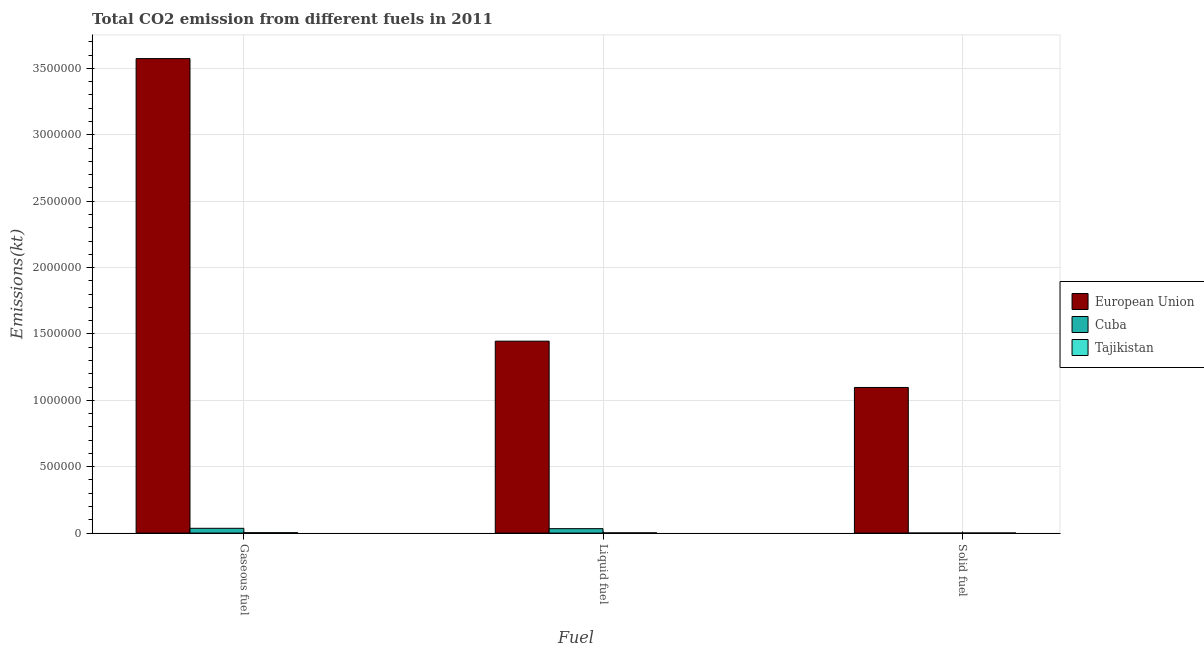How many groups of bars are there?
Your response must be concise. 3. Are the number of bars per tick equal to the number of legend labels?
Offer a terse response. Yes. Are the number of bars on each tick of the X-axis equal?
Give a very brief answer. Yes. How many bars are there on the 1st tick from the right?
Make the answer very short. 3. What is the label of the 2nd group of bars from the left?
Ensure brevity in your answer.  Liquid fuel. What is the amount of co2 emissions from solid fuel in Tajikistan?
Your response must be concise. 348.37. Across all countries, what is the maximum amount of co2 emissions from liquid fuel?
Your answer should be very brief. 1.45e+06. Across all countries, what is the minimum amount of co2 emissions from solid fuel?
Offer a terse response. 11. In which country was the amount of co2 emissions from gaseous fuel maximum?
Your answer should be very brief. European Union. In which country was the amount of co2 emissions from liquid fuel minimum?
Offer a terse response. Tajikistan. What is the total amount of co2 emissions from gaseous fuel in the graph?
Your answer should be very brief. 3.61e+06. What is the difference between the amount of co2 emissions from liquid fuel in European Union and that in Tajikistan?
Your response must be concise. 1.44e+06. What is the difference between the amount of co2 emissions from solid fuel in Tajikistan and the amount of co2 emissions from gaseous fuel in Cuba?
Provide a succinct answer. -3.56e+04. What is the average amount of co2 emissions from gaseous fuel per country?
Your answer should be compact. 1.20e+06. What is the difference between the amount of co2 emissions from liquid fuel and amount of co2 emissions from gaseous fuel in European Union?
Provide a succinct answer. -2.13e+06. In how many countries, is the amount of co2 emissions from solid fuel greater than 1000000 kt?
Your answer should be very brief. 1. What is the ratio of the amount of co2 emissions from liquid fuel in Cuba to that in European Union?
Give a very brief answer. 0.02. Is the amount of co2 emissions from gaseous fuel in Cuba less than that in Tajikistan?
Your response must be concise. No. What is the difference between the highest and the second highest amount of co2 emissions from solid fuel?
Your response must be concise. 1.10e+06. What is the difference between the highest and the lowest amount of co2 emissions from gaseous fuel?
Ensure brevity in your answer.  3.57e+06. In how many countries, is the amount of co2 emissions from solid fuel greater than the average amount of co2 emissions from solid fuel taken over all countries?
Provide a succinct answer. 1. What does the 2nd bar from the left in Gaseous fuel represents?
Keep it short and to the point. Cuba. What does the 2nd bar from the right in Solid fuel represents?
Make the answer very short. Cuba. Are all the bars in the graph horizontal?
Your answer should be very brief. No. Are the values on the major ticks of Y-axis written in scientific E-notation?
Keep it short and to the point. No. Does the graph contain any zero values?
Your response must be concise. No. Where does the legend appear in the graph?
Give a very brief answer. Center right. How many legend labels are there?
Provide a succinct answer. 3. What is the title of the graph?
Ensure brevity in your answer.  Total CO2 emission from different fuels in 2011. Does "Pacific island small states" appear as one of the legend labels in the graph?
Give a very brief answer. No. What is the label or title of the X-axis?
Ensure brevity in your answer.  Fuel. What is the label or title of the Y-axis?
Provide a short and direct response. Emissions(kt). What is the Emissions(kt) in European Union in Gaseous fuel?
Provide a short and direct response. 3.57e+06. What is the Emissions(kt) of Cuba in Gaseous fuel?
Provide a short and direct response. 3.59e+04. What is the Emissions(kt) of Tajikistan in Gaseous fuel?
Offer a terse response. 2783.25. What is the Emissions(kt) of European Union in Liquid fuel?
Ensure brevity in your answer.  1.45e+06. What is the Emissions(kt) of Cuba in Liquid fuel?
Give a very brief answer. 3.31e+04. What is the Emissions(kt) in Tajikistan in Liquid fuel?
Your answer should be very brief. 1481.47. What is the Emissions(kt) in European Union in Solid fuel?
Your answer should be compact. 1.10e+06. What is the Emissions(kt) of Cuba in Solid fuel?
Keep it short and to the point. 11. What is the Emissions(kt) in Tajikistan in Solid fuel?
Give a very brief answer. 348.37. Across all Fuel, what is the maximum Emissions(kt) of European Union?
Offer a very short reply. 3.57e+06. Across all Fuel, what is the maximum Emissions(kt) of Cuba?
Your answer should be compact. 3.59e+04. Across all Fuel, what is the maximum Emissions(kt) of Tajikistan?
Your answer should be very brief. 2783.25. Across all Fuel, what is the minimum Emissions(kt) in European Union?
Give a very brief answer. 1.10e+06. Across all Fuel, what is the minimum Emissions(kt) in Cuba?
Your response must be concise. 11. Across all Fuel, what is the minimum Emissions(kt) in Tajikistan?
Ensure brevity in your answer.  348.37. What is the total Emissions(kt) in European Union in the graph?
Make the answer very short. 6.12e+06. What is the total Emissions(kt) of Cuba in the graph?
Ensure brevity in your answer.  6.91e+04. What is the total Emissions(kt) in Tajikistan in the graph?
Make the answer very short. 4613.09. What is the difference between the Emissions(kt) in European Union in Gaseous fuel and that in Liquid fuel?
Keep it short and to the point. 2.13e+06. What is the difference between the Emissions(kt) in Cuba in Gaseous fuel and that in Liquid fuel?
Provide a succinct answer. 2772.25. What is the difference between the Emissions(kt) in Tajikistan in Gaseous fuel and that in Liquid fuel?
Your answer should be very brief. 1301.79. What is the difference between the Emissions(kt) in European Union in Gaseous fuel and that in Solid fuel?
Offer a terse response. 2.48e+06. What is the difference between the Emissions(kt) of Cuba in Gaseous fuel and that in Solid fuel?
Make the answer very short. 3.59e+04. What is the difference between the Emissions(kt) of Tajikistan in Gaseous fuel and that in Solid fuel?
Offer a terse response. 2434.89. What is the difference between the Emissions(kt) of European Union in Liquid fuel and that in Solid fuel?
Ensure brevity in your answer.  3.49e+05. What is the difference between the Emissions(kt) in Cuba in Liquid fuel and that in Solid fuel?
Offer a very short reply. 3.31e+04. What is the difference between the Emissions(kt) of Tajikistan in Liquid fuel and that in Solid fuel?
Provide a short and direct response. 1133.1. What is the difference between the Emissions(kt) of European Union in Gaseous fuel and the Emissions(kt) of Cuba in Liquid fuel?
Provide a succinct answer. 3.54e+06. What is the difference between the Emissions(kt) of European Union in Gaseous fuel and the Emissions(kt) of Tajikistan in Liquid fuel?
Offer a terse response. 3.57e+06. What is the difference between the Emissions(kt) in Cuba in Gaseous fuel and the Emissions(kt) in Tajikistan in Liquid fuel?
Keep it short and to the point. 3.44e+04. What is the difference between the Emissions(kt) in European Union in Gaseous fuel and the Emissions(kt) in Cuba in Solid fuel?
Your answer should be very brief. 3.57e+06. What is the difference between the Emissions(kt) in European Union in Gaseous fuel and the Emissions(kt) in Tajikistan in Solid fuel?
Give a very brief answer. 3.57e+06. What is the difference between the Emissions(kt) in Cuba in Gaseous fuel and the Emissions(kt) in Tajikistan in Solid fuel?
Your response must be concise. 3.56e+04. What is the difference between the Emissions(kt) in European Union in Liquid fuel and the Emissions(kt) in Cuba in Solid fuel?
Give a very brief answer. 1.45e+06. What is the difference between the Emissions(kt) in European Union in Liquid fuel and the Emissions(kt) in Tajikistan in Solid fuel?
Your response must be concise. 1.45e+06. What is the difference between the Emissions(kt) in Cuba in Liquid fuel and the Emissions(kt) in Tajikistan in Solid fuel?
Your answer should be very brief. 3.28e+04. What is the average Emissions(kt) of European Union per Fuel?
Your answer should be very brief. 2.04e+06. What is the average Emissions(kt) in Cuba per Fuel?
Provide a succinct answer. 2.30e+04. What is the average Emissions(kt) of Tajikistan per Fuel?
Make the answer very short. 1537.7. What is the difference between the Emissions(kt) of European Union and Emissions(kt) of Cuba in Gaseous fuel?
Offer a very short reply. 3.54e+06. What is the difference between the Emissions(kt) in European Union and Emissions(kt) in Tajikistan in Gaseous fuel?
Your response must be concise. 3.57e+06. What is the difference between the Emissions(kt) in Cuba and Emissions(kt) in Tajikistan in Gaseous fuel?
Give a very brief answer. 3.31e+04. What is the difference between the Emissions(kt) of European Union and Emissions(kt) of Cuba in Liquid fuel?
Your answer should be compact. 1.41e+06. What is the difference between the Emissions(kt) of European Union and Emissions(kt) of Tajikistan in Liquid fuel?
Your response must be concise. 1.44e+06. What is the difference between the Emissions(kt) in Cuba and Emissions(kt) in Tajikistan in Liquid fuel?
Make the answer very short. 3.17e+04. What is the difference between the Emissions(kt) in European Union and Emissions(kt) in Cuba in Solid fuel?
Your answer should be very brief. 1.10e+06. What is the difference between the Emissions(kt) in European Union and Emissions(kt) in Tajikistan in Solid fuel?
Make the answer very short. 1.10e+06. What is the difference between the Emissions(kt) of Cuba and Emissions(kt) of Tajikistan in Solid fuel?
Make the answer very short. -337.36. What is the ratio of the Emissions(kt) of European Union in Gaseous fuel to that in Liquid fuel?
Give a very brief answer. 2.47. What is the ratio of the Emissions(kt) of Cuba in Gaseous fuel to that in Liquid fuel?
Offer a terse response. 1.08. What is the ratio of the Emissions(kt) of Tajikistan in Gaseous fuel to that in Liquid fuel?
Give a very brief answer. 1.88. What is the ratio of the Emissions(kt) in European Union in Gaseous fuel to that in Solid fuel?
Make the answer very short. 3.26. What is the ratio of the Emissions(kt) in Cuba in Gaseous fuel to that in Solid fuel?
Your answer should be compact. 3265.33. What is the ratio of the Emissions(kt) of Tajikistan in Gaseous fuel to that in Solid fuel?
Provide a succinct answer. 7.99. What is the ratio of the Emissions(kt) in European Union in Liquid fuel to that in Solid fuel?
Offer a terse response. 1.32. What is the ratio of the Emissions(kt) in Cuba in Liquid fuel to that in Solid fuel?
Provide a short and direct response. 3013.33. What is the ratio of the Emissions(kt) of Tajikistan in Liquid fuel to that in Solid fuel?
Keep it short and to the point. 4.25. What is the difference between the highest and the second highest Emissions(kt) in European Union?
Your response must be concise. 2.13e+06. What is the difference between the highest and the second highest Emissions(kt) in Cuba?
Make the answer very short. 2772.25. What is the difference between the highest and the second highest Emissions(kt) of Tajikistan?
Your response must be concise. 1301.79. What is the difference between the highest and the lowest Emissions(kt) of European Union?
Keep it short and to the point. 2.48e+06. What is the difference between the highest and the lowest Emissions(kt) of Cuba?
Provide a succinct answer. 3.59e+04. What is the difference between the highest and the lowest Emissions(kt) of Tajikistan?
Offer a very short reply. 2434.89. 